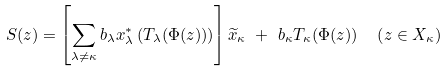Convert formula to latex. <formula><loc_0><loc_0><loc_500><loc_500>S ( z ) & = \left [ \sum _ { \lambda \neq \kappa } b _ { \lambda } x _ { \lambda } ^ { * } \left ( T _ { \lambda } ( \Phi ( z ) ) \right ) \right ] \widetilde { x } _ { \kappa } \ + \ b _ { \kappa } T _ { \kappa } ( \Phi ( z ) ) \quad \left ( z \in X _ { \kappa } \right )</formula> 